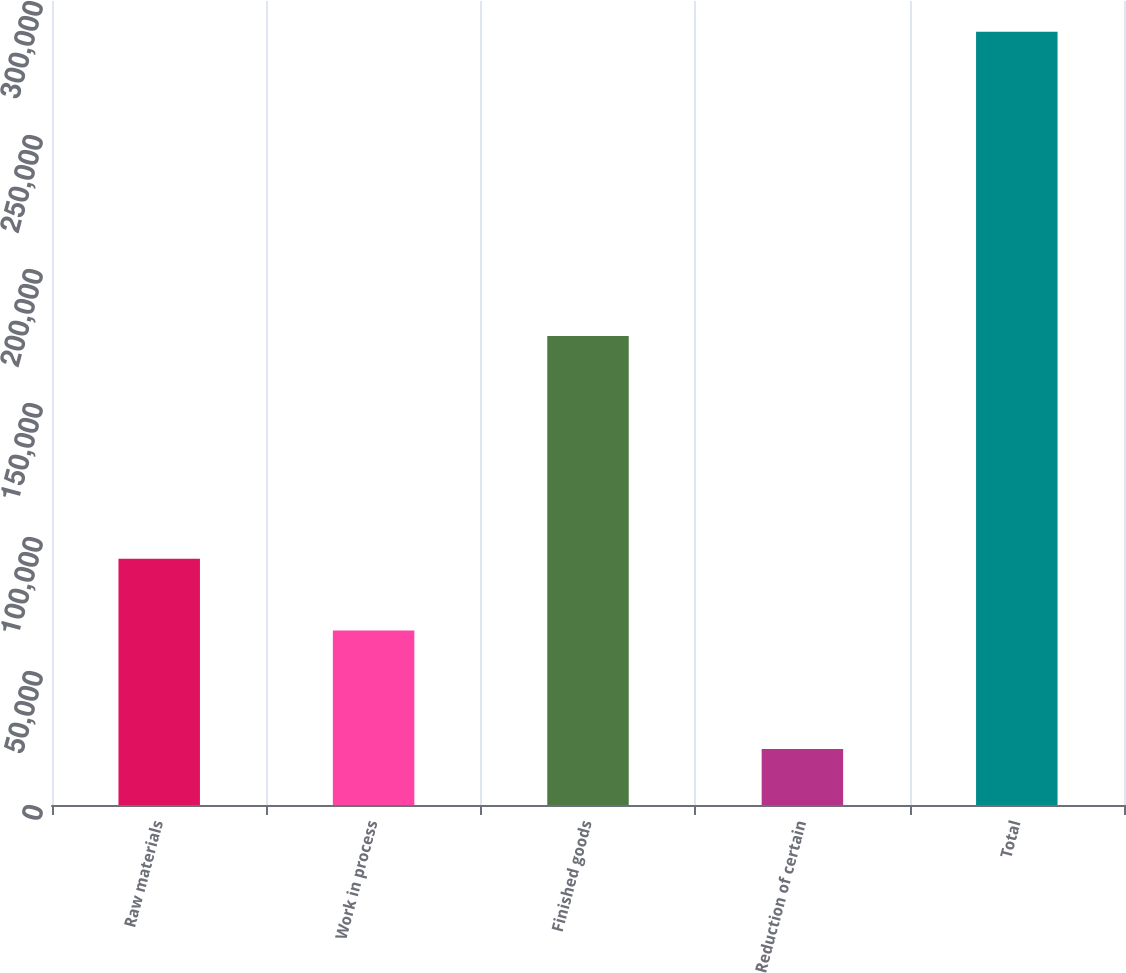<chart> <loc_0><loc_0><loc_500><loc_500><bar_chart><fcel>Raw materials<fcel>Work in process<fcel>Finished goods<fcel>Reduction of certain<fcel>Total<nl><fcel>91919.2<fcel>65148<fcel>174968<fcel>20858<fcel>288570<nl></chart> 